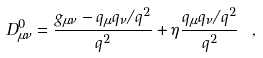<formula> <loc_0><loc_0><loc_500><loc_500>D _ { \mu \nu } ^ { 0 } = { \frac { g _ { \mu \nu } - q _ { \mu } q _ { \nu } / q ^ { 2 } } { q ^ { 2 } } } + \eta { \frac { q _ { \mu } q _ { \nu } / q ^ { 2 } } { q ^ { 2 } } } \ ,</formula> 